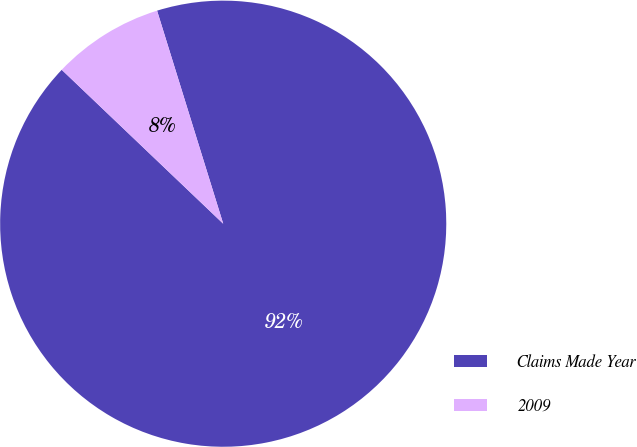Convert chart. <chart><loc_0><loc_0><loc_500><loc_500><pie_chart><fcel>Claims Made Year<fcel>2009<nl><fcel>91.91%<fcel>8.09%<nl></chart> 